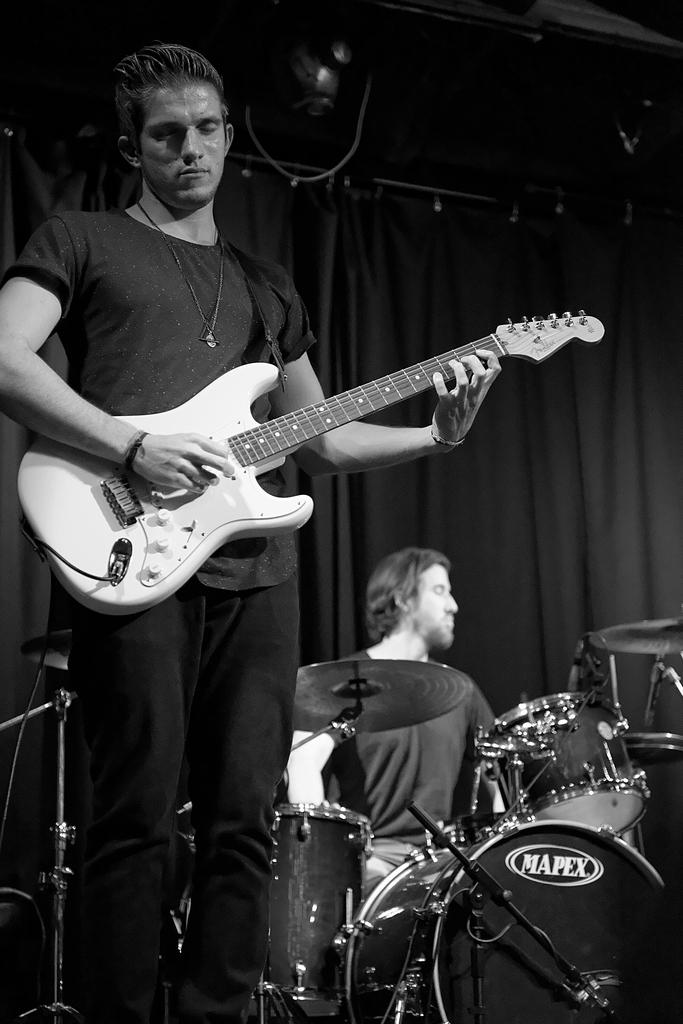What is the person in the image holding? The person in the image is holding a guitar. What is the man in the image doing? The man in the image is playing a musical instrument. Where is the giraffe sitting in the image? There is no giraffe present in the image. What type of trade is being conducted in the image? There is no trade being conducted in the image; it features a person holding a guitar and a man playing a musical instrument. 